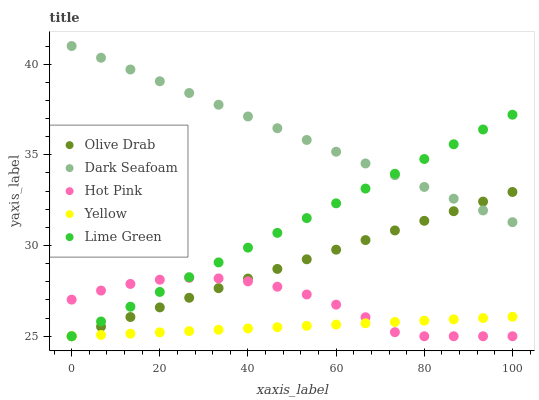Does Yellow have the minimum area under the curve?
Answer yes or no. Yes. Does Dark Seafoam have the maximum area under the curve?
Answer yes or no. Yes. Does Hot Pink have the minimum area under the curve?
Answer yes or no. No. Does Hot Pink have the maximum area under the curve?
Answer yes or no. No. Is Yellow the smoothest?
Answer yes or no. Yes. Is Hot Pink the roughest?
Answer yes or no. Yes. Is Lime Green the smoothest?
Answer yes or no. No. Is Lime Green the roughest?
Answer yes or no. No. Does Hot Pink have the lowest value?
Answer yes or no. Yes. Does Dark Seafoam have the highest value?
Answer yes or no. Yes. Does Hot Pink have the highest value?
Answer yes or no. No. Is Yellow less than Dark Seafoam?
Answer yes or no. Yes. Is Dark Seafoam greater than Hot Pink?
Answer yes or no. Yes. Does Lime Green intersect Olive Drab?
Answer yes or no. Yes. Is Lime Green less than Olive Drab?
Answer yes or no. No. Is Lime Green greater than Olive Drab?
Answer yes or no. No. Does Yellow intersect Dark Seafoam?
Answer yes or no. No. 